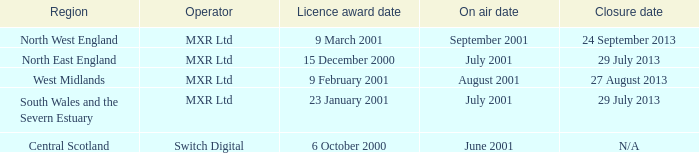What is the license award date for North East England? 15 December 2000. 